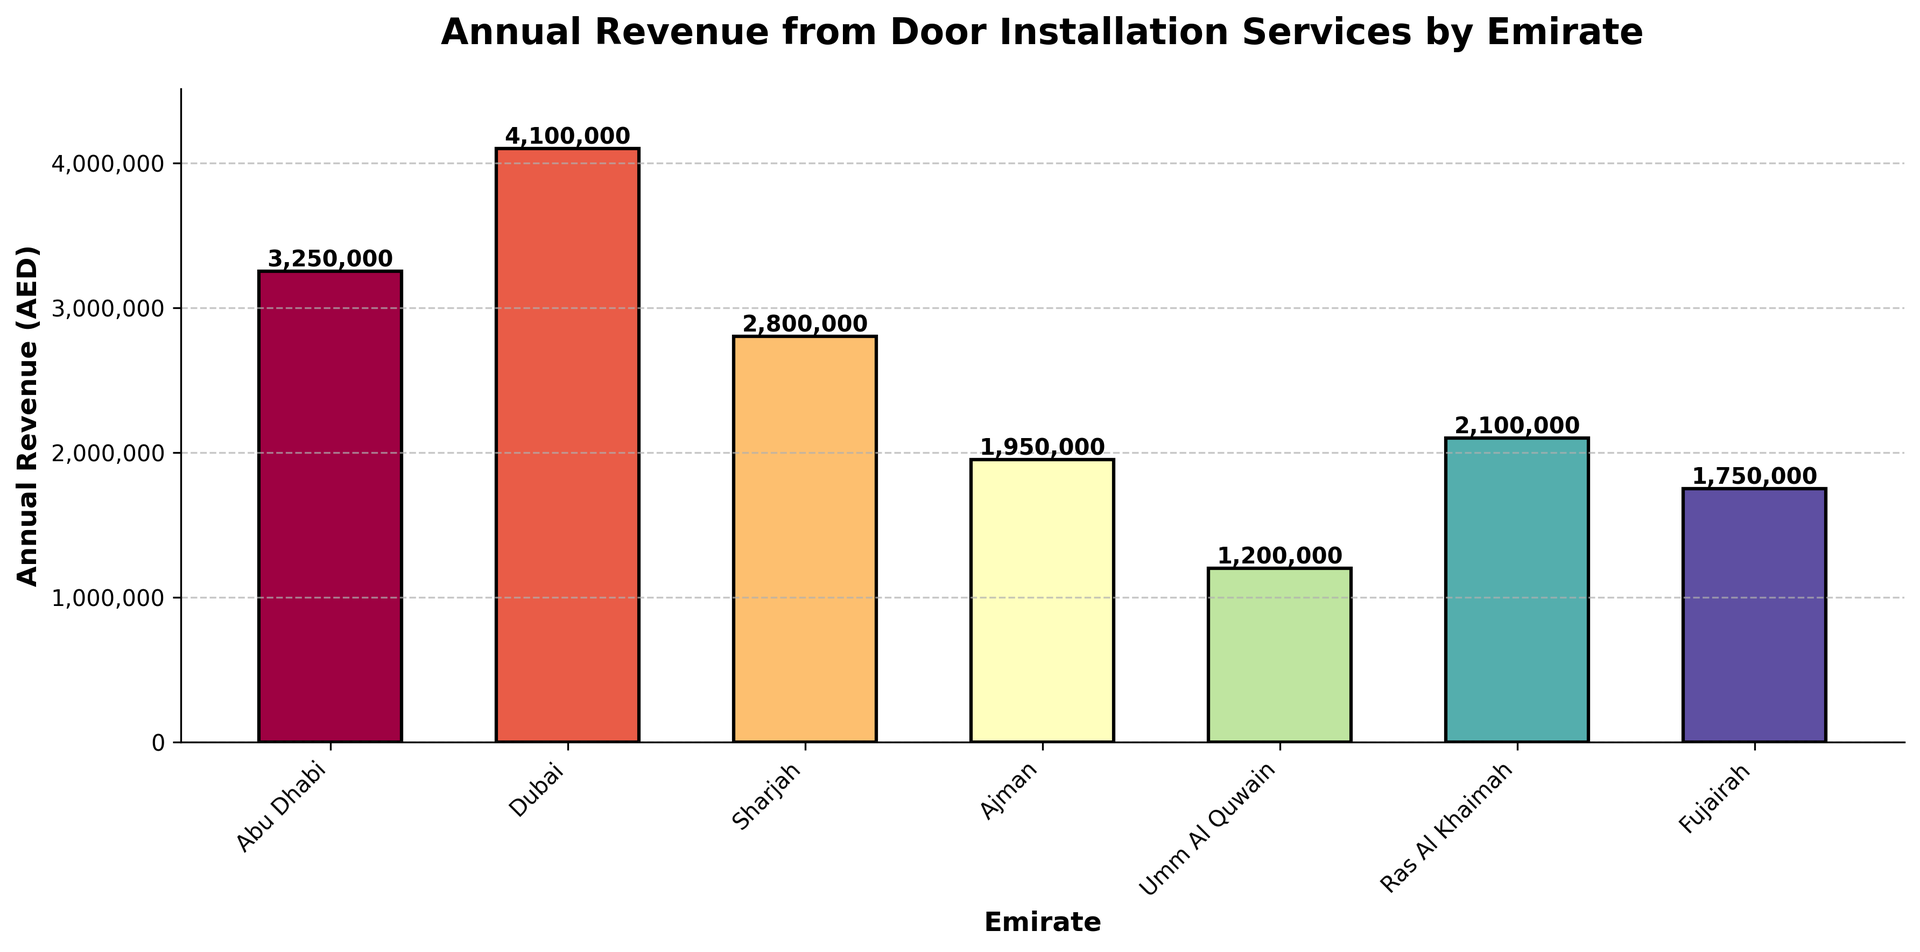Which Emirate generated the highest annual revenue from door installation services? The bar chart shows that Dubai has the tallest bar, indicating that Dubai generated the highest annual revenue.
Answer: Dubai Which Emirate generated the lowest annual revenue from door installation services? The bar chart shows that Umm Al Quwain has the shortest bar, indicating that Umm Al Quwain generated the lowest annual revenue.
Answer: Umm Al Quwain How much more revenue did Dubai generate compared to Ras Al Khaimah? According to the chart, Dubai generated AED 4,100,000 and Ras Al Khaimah generated AED 2,100,000. The difference is AED 4,100,000 - AED 2,100,000 = AED 2,000,000.
Answer: AED 2,000,000 What is the average annual revenue from door installation services across all Emirates? Sum the revenues and divide by the number of Emirates. Total revenue: 3,250,000 + 4,100,000 + 2,800,000 + 1,950,000 + 1,200,000 + 2,100,000 + 1,750,000 = 17,150,000. Number of Emirates: 7. Average revenue: 17,150,000 / 7 = 2,450,000 AED
Answer: 2,450,000 AED Which Emirate’s revenue is closest to the average annual revenue? Calculate the average annual revenue, which is 2,450,000 AED. Compare each Emirate's revenue to this value. Sharjah's revenue, 2,800,000 AED, is the closest.
Answer: Sharjah By how much did Sharjah's revenue exceed Fujairah's revenue? According to the chart, Sharjah's revenue is AED 2,800,000 and Fujairah is AED 1,750,000. The difference is AED 2,800,000 - AED 1,750,000 = AED 1,050,000.
Answer: AED 1,050,000 What is the combined revenue of Abu Dhabi, Ajman, and Fujairah? Sum the revenues of the three Emirates: Abu Dhabi (3,250,000) + Ajman (1,950,000) + Fujairah (1,750,000) = AED 6,950,000.
Answer: AED 6,950,000 If Umm Al Quwain doubled its revenue, would it surpass Ras Al Khaimah? Umm Al Quwain's revenue is AED 1,200,000. If it doubled, it would be 1,200,000 * 2 = 2,400,000. Compare this to Ras Al Khaimah's revenue of 2,100,000. Yes, it would surpass Ras Al Khaimah.
Answer: Yes Which two Emirates have the smallest gap in their annual revenues? Calculate the differences between the revenues of each pair of Emirates. The smallest difference is between Ras Al Khaimah (2,100,000) and Fujairah (1,750,000), which is AED 2,100,000 - AED 1,750,000 = AED 350,000.
Answer: Ras Al Khaimah and Fujairah 